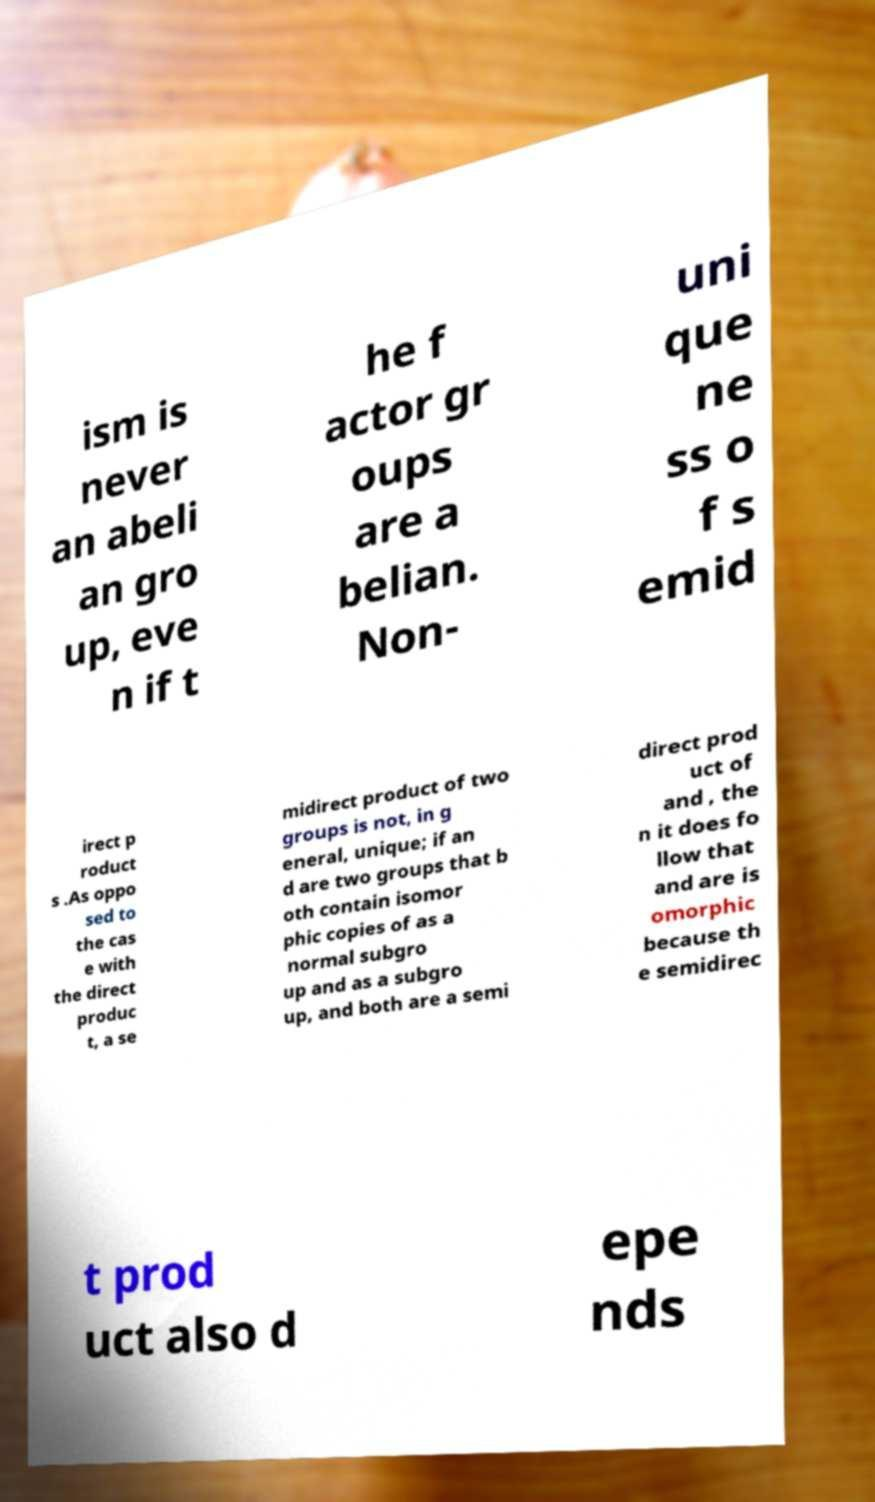Can you read and provide the text displayed in the image?This photo seems to have some interesting text. Can you extract and type it out for me? ism is never an abeli an gro up, eve n if t he f actor gr oups are a belian. Non- uni que ne ss o f s emid irect p roduct s .As oppo sed to the cas e with the direct produc t, a se midirect product of two groups is not, in g eneral, unique; if an d are two groups that b oth contain isomor phic copies of as a normal subgro up and as a subgro up, and both are a semi direct prod uct of and , the n it does fo llow that and are is omorphic because th e semidirec t prod uct also d epe nds 